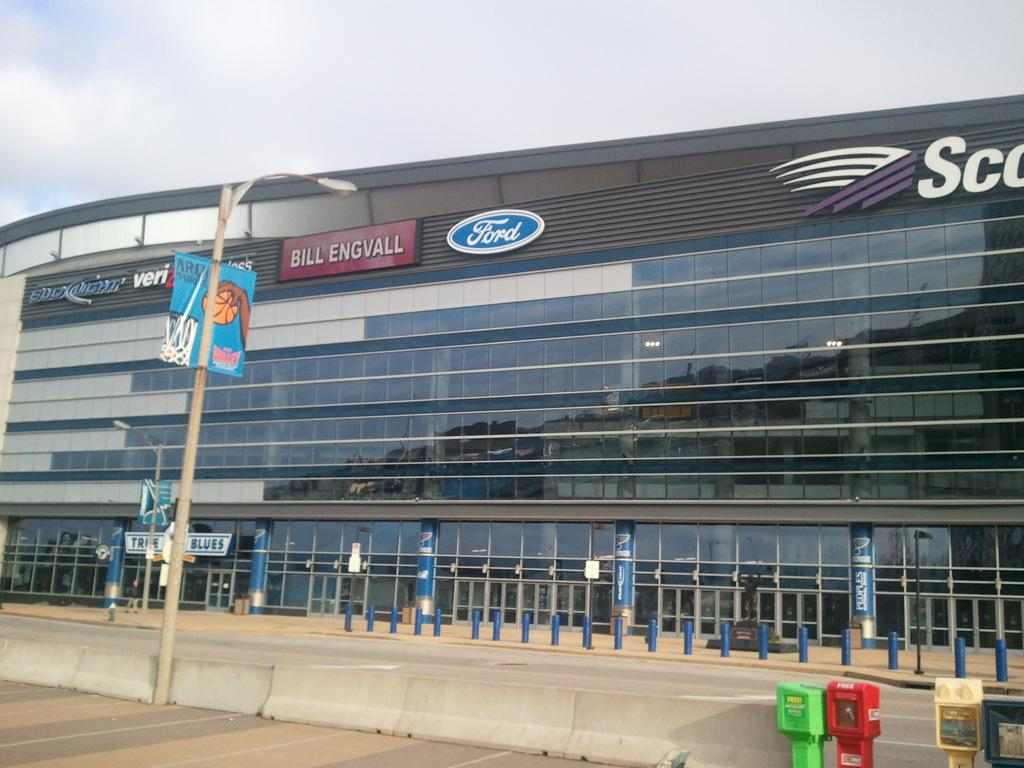What type of structure is present in the picture? There is a building in the picture. What other objects can be seen in the picture besides the building? There are poles, boards, lights, and other objects in the picture. Can you describe the lighting in the picture? There are lights present in the picture. What can be seen in the background of the picture? The sky is visible in the background of the picture. How many frogs are jumping on the shoes in the picture? There are no frogs or shoes present in the picture. What is the source of the surprise in the picture? There is no surprise or any indication of surprise in the picture. 